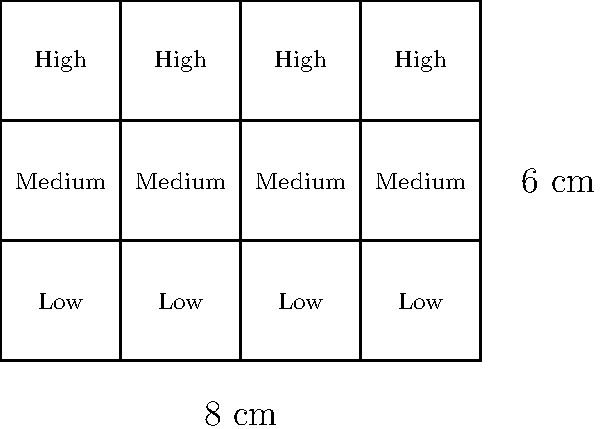A risk assessment matrix is visualized as a rectangle with internal divisions, representing different risk categories and levels. The matrix measures 8 cm in width and 6 cm in height, with 3 horizontal divisions and 4 vertical divisions. What is the perimeter of the entire risk assessment matrix in centimeters? To calculate the perimeter of the risk assessment matrix, we need to sum up the lengths of all sides of the rectangle. Let's break it down step-by-step:

1. Identify the dimensions:
   - Width (w) = 8 cm
   - Height (h) = 6 cm

2. Calculate the perimeter using the formula for a rectangle:
   Perimeter = 2(width + height)
   
3. Substitute the values:
   Perimeter = 2(8 cm + 6 cm)
   
4. Perform the addition inside the parentheses:
   Perimeter = 2(14 cm)
   
5. Multiply:
   Perimeter = 28 cm

Therefore, the perimeter of the entire risk assessment matrix is 28 cm.

Note: The internal divisions do not affect the perimeter calculation, as we are only concerned with the outer edges of the rectangle.
Answer: 28 cm 